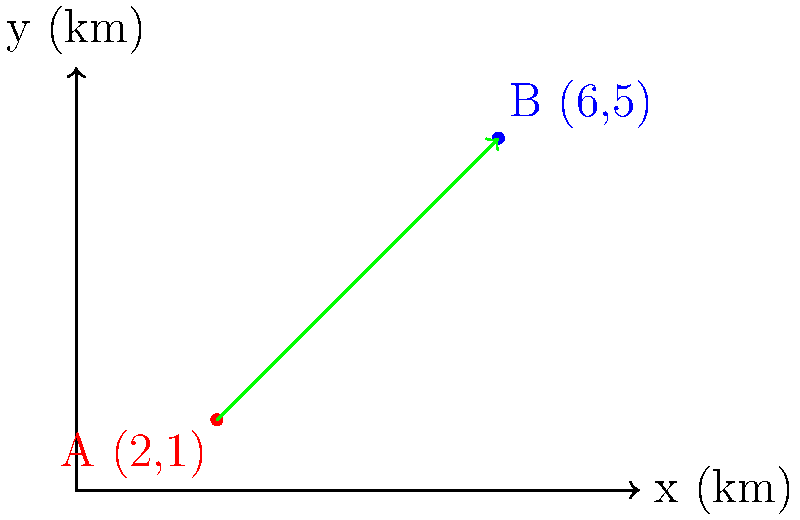During an air show, two performance points A and B are marked on a coordinate system as shown in the diagram. Point A is located at (2 km, 1 km) and point B is at (6 km, 5 km). What is the magnitude of the vector representing the distance between these two performance points? To find the magnitude of the vector between points A and B, we can follow these steps:

1. Identify the coordinates:
   Point A: (2, 1)
   Point B: (6, 5)

2. Calculate the components of the vector:
   x-component: $6 - 2 = 4$ km
   y-component: $5 - 1 = 4$ km

3. Use the Pythagorean theorem to find the magnitude:
   $\text{magnitude} = \sqrt{(\text{x-component})^2 + (\text{y-component})^2}$

4. Substitute the values:
   $\text{magnitude} = \sqrt{4^2 + 4^2}$

5. Simplify:
   $\text{magnitude} = \sqrt{16 + 16} = \sqrt{32}$

6. Simplify the square root:
   $\text{magnitude} = 4\sqrt{2}$ km

Therefore, the magnitude of the vector representing the distance between the two performance points is $4\sqrt{2}$ km.
Answer: $4\sqrt{2}$ km 